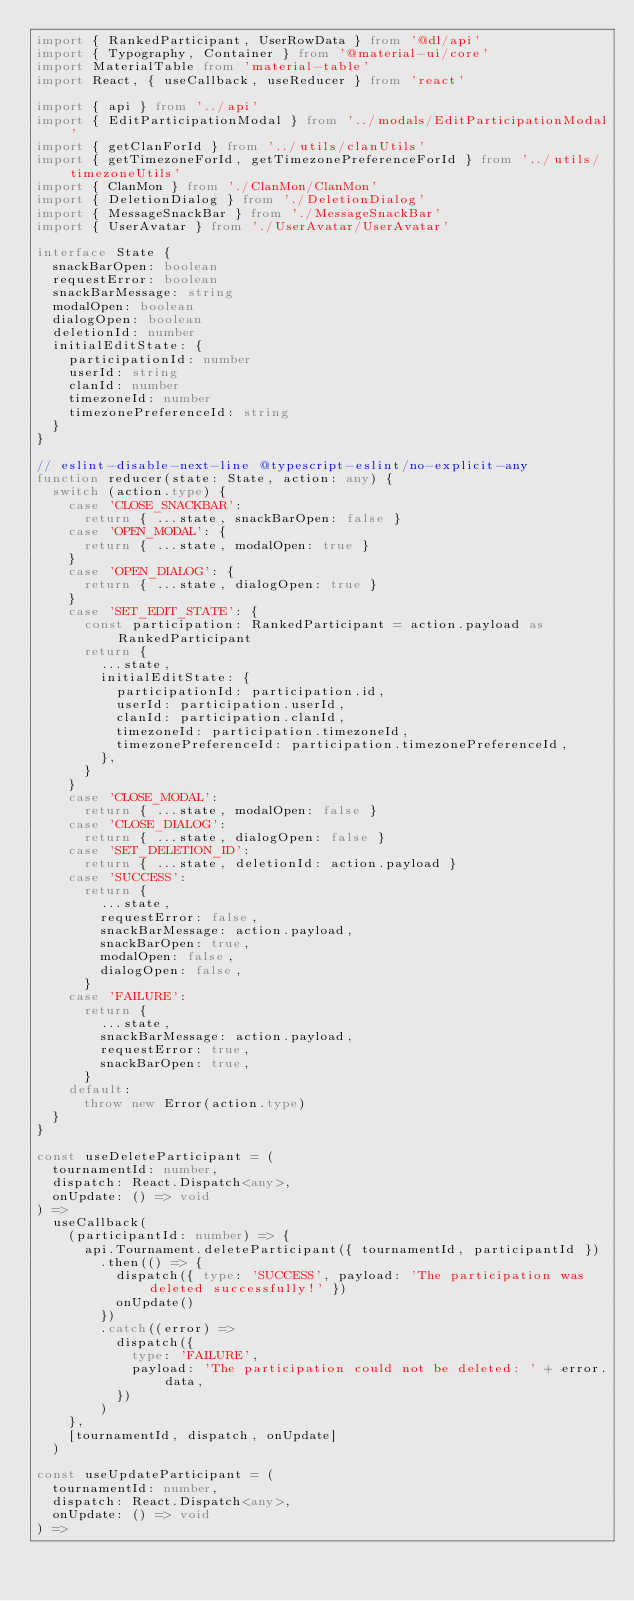<code> <loc_0><loc_0><loc_500><loc_500><_TypeScript_>import { RankedParticipant, UserRowData } from '@dl/api'
import { Typography, Container } from '@material-ui/core'
import MaterialTable from 'material-table'
import React, { useCallback, useReducer } from 'react'

import { api } from '../api'
import { EditParticipationModal } from '../modals/EditParticipationModal'
import { getClanForId } from '../utils/clanUtils'
import { getTimezoneForId, getTimezonePreferenceForId } from '../utils/timezoneUtils'
import { ClanMon } from './ClanMon/ClanMon'
import { DeletionDialog } from './DeletionDialog'
import { MessageSnackBar } from './MessageSnackBar'
import { UserAvatar } from './UserAvatar/UserAvatar'

interface State {
  snackBarOpen: boolean
  requestError: boolean
  snackBarMessage: string
  modalOpen: boolean
  dialogOpen: boolean
  deletionId: number
  initialEditState: {
    participationId: number
    userId: string
    clanId: number
    timezoneId: number
    timezonePreferenceId: string
  }
}

// eslint-disable-next-line @typescript-eslint/no-explicit-any
function reducer(state: State, action: any) {
  switch (action.type) {
    case 'CLOSE_SNACKBAR':
      return { ...state, snackBarOpen: false }
    case 'OPEN_MODAL': {
      return { ...state, modalOpen: true }
    }
    case 'OPEN_DIALOG': {
      return { ...state, dialogOpen: true }
    }
    case 'SET_EDIT_STATE': {
      const participation: RankedParticipant = action.payload as RankedParticipant
      return {
        ...state,
        initialEditState: {
          participationId: participation.id,
          userId: participation.userId,
          clanId: participation.clanId,
          timezoneId: participation.timezoneId,
          timezonePreferenceId: participation.timezonePreferenceId,
        },
      }
    }
    case 'CLOSE_MODAL':
      return { ...state, modalOpen: false }
    case 'CLOSE_DIALOG':
      return { ...state, dialogOpen: false }
    case 'SET_DELETION_ID':
      return { ...state, deletionId: action.payload }
    case 'SUCCESS':
      return {
        ...state,
        requestError: false,
        snackBarMessage: action.payload,
        snackBarOpen: true,
        modalOpen: false,
        dialogOpen: false,
      }
    case 'FAILURE':
      return {
        ...state,
        snackBarMessage: action.payload,
        requestError: true,
        snackBarOpen: true,
      }
    default:
      throw new Error(action.type)
  }
}

const useDeleteParticipant = (
  tournamentId: number,
  dispatch: React.Dispatch<any>,
  onUpdate: () => void
) =>
  useCallback(
    (participantId: number) => {
      api.Tournament.deleteParticipant({ tournamentId, participantId })
        .then(() => {
          dispatch({ type: 'SUCCESS', payload: 'The participation was deleted successfully!' })
          onUpdate()
        })
        .catch((error) =>
          dispatch({
            type: 'FAILURE',
            payload: 'The participation could not be deleted: ' + error.data,
          })
        )
    },
    [tournamentId, dispatch, onUpdate]
  )

const useUpdateParticipant = (
  tournamentId: number,
  dispatch: React.Dispatch<any>,
  onUpdate: () => void
) =></code> 